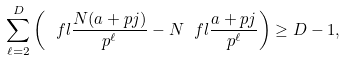<formula> <loc_0><loc_0><loc_500><loc_500>\sum _ { \ell = 2 } ^ { D } \left ( \ f l { \frac { N ( a + p j ) } { p ^ { \ell } } } - N \ f l { \frac { a + p j } { p ^ { \ell } } } \right ) \geq D - 1 ,</formula> 